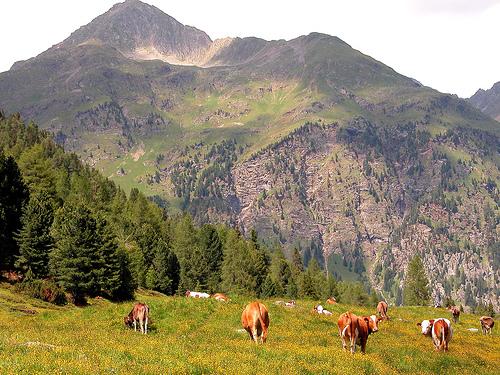How many animals are in this scene?
Quick response, please. 12. Where are the two cows in the left foreground looking?
Be succinct. Down. How many cows are in the background?
Concise answer only. 12. It's this scene taking place in Kansas?
Keep it brief. No. What nation are these animals native to?
Quick response, please. America. What color are these animals?
Answer briefly. Brown and white. How many cows  are here?
Write a very short answer. 12. How many animal are there?
Write a very short answer. 12. 